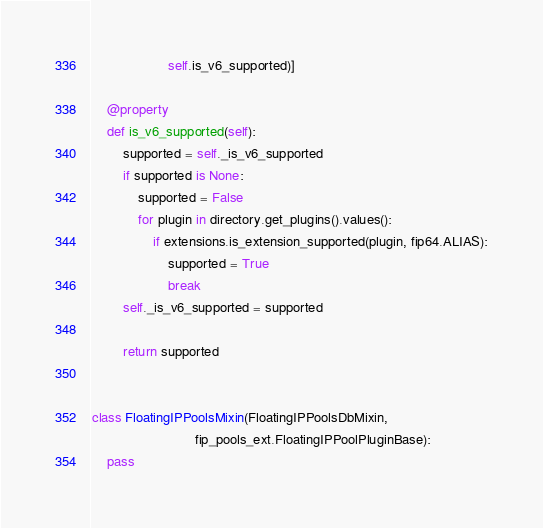<code> <loc_0><loc_0><loc_500><loc_500><_Python_>                    self.is_v6_supported)]

    @property
    def is_v6_supported(self):
        supported = self._is_v6_supported
        if supported is None:
            supported = False
            for plugin in directory.get_plugins().values():
                if extensions.is_extension_supported(plugin, fip64.ALIAS):
                    supported = True
                    break
        self._is_v6_supported = supported

        return supported


class FloatingIPPoolsMixin(FloatingIPPoolsDbMixin,
                           fip_pools_ext.FloatingIPPoolPluginBase):
    pass
</code> 